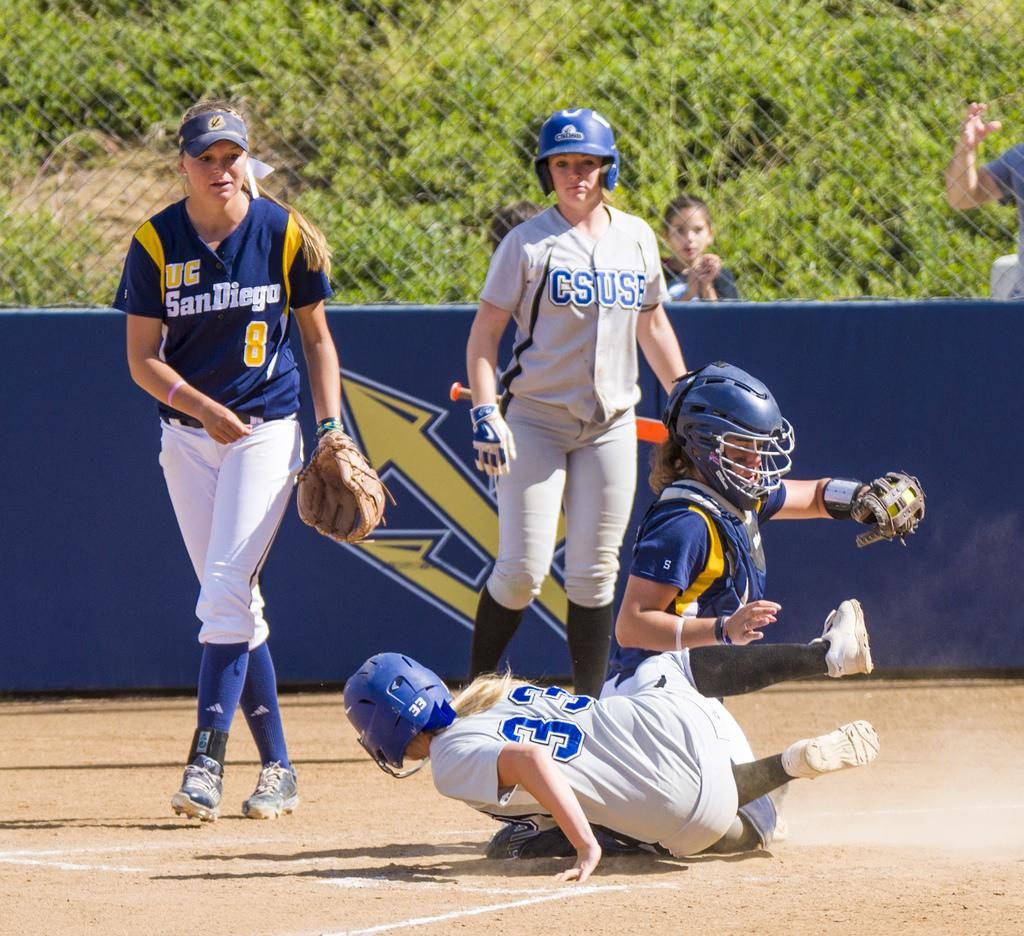<image>
Relay a brief, clear account of the picture shown. Female softball players on Sn Diego and CSUSE teams are in the middle of a play at home base. 